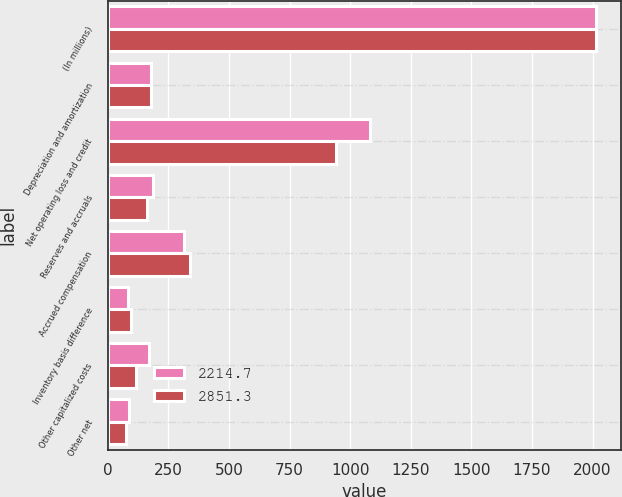<chart> <loc_0><loc_0><loc_500><loc_500><stacked_bar_chart><ecel><fcel>(In millions)<fcel>Depreciation and amortization<fcel>Net operating loss and credit<fcel>Reserves and accruals<fcel>Accrued compensation<fcel>Inventory basis difference<fcel>Other capitalized costs<fcel>Other net<nl><fcel>2214.7<fcel>2015<fcel>176.9<fcel>1083.3<fcel>185.9<fcel>312.9<fcel>83.3<fcel>167.9<fcel>85.7<nl><fcel>2851.3<fcel>2014<fcel>176.9<fcel>941.9<fcel>163.1<fcel>339.1<fcel>96.6<fcel>116<fcel>77<nl></chart> 